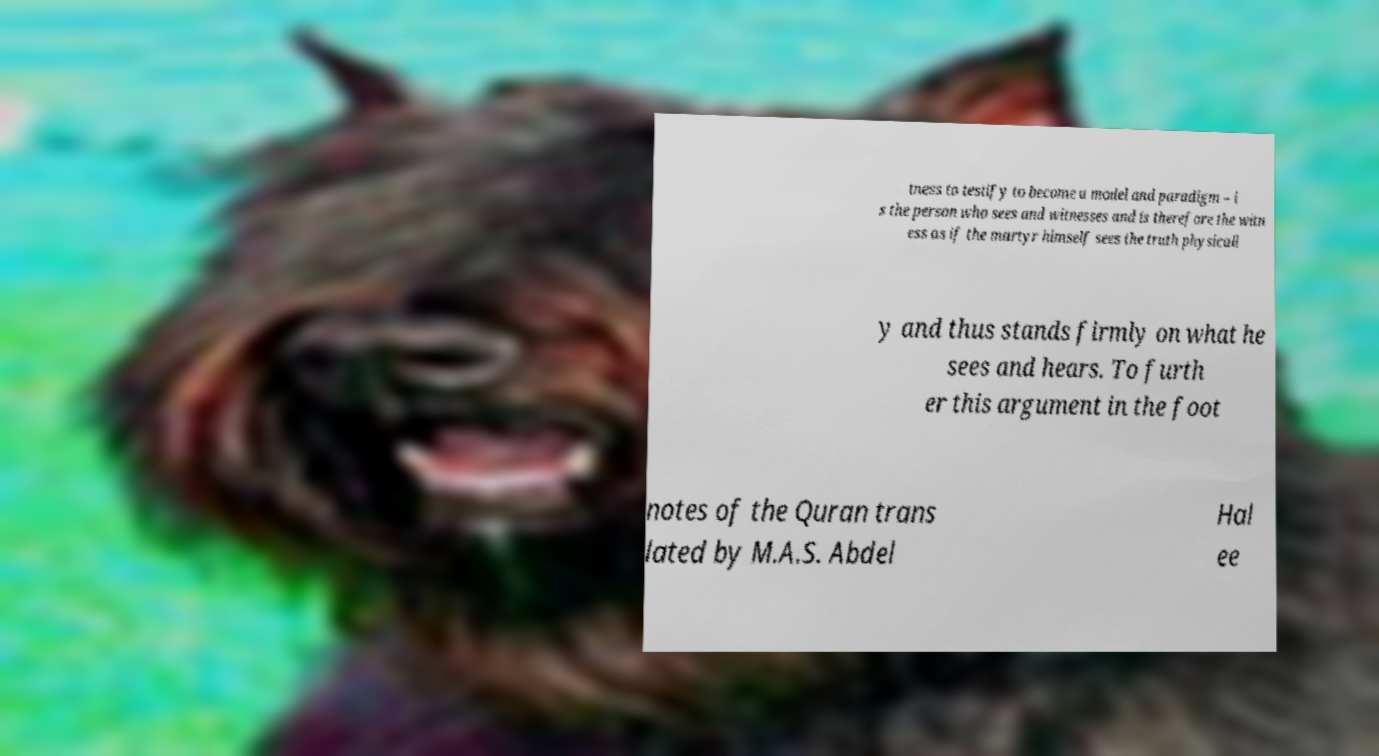I need the written content from this picture converted into text. Can you do that? tness to testify to become a model and paradigm – i s the person who sees and witnesses and is therefore the witn ess as if the martyr himself sees the truth physicall y and thus stands firmly on what he sees and hears. To furth er this argument in the foot notes of the Quran trans lated by M.A.S. Abdel Hal ee 